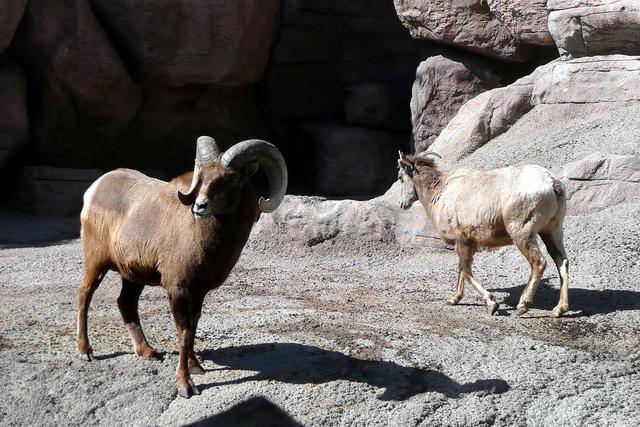How many sheep are visible?
Give a very brief answer. 2. How many people are wearing helmet?
Give a very brief answer. 0. 